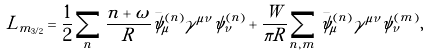<formula> <loc_0><loc_0><loc_500><loc_500>L _ { m _ { 3 / 2 } } = \frac { 1 } { 2 } \sum _ { n } \frac { n + \omega } { R } \bar { \psi } _ { \mu } ^ { ( n ) } \gamma ^ { \mu \nu } \psi _ { \nu } ^ { ( n ) } + \frac { W } { \pi R } \sum _ { n , m } \bar { \psi } _ { \mu } ^ { ( n ) } \gamma ^ { \mu \nu } \psi _ { \nu } ^ { ( m ) } ,</formula> 